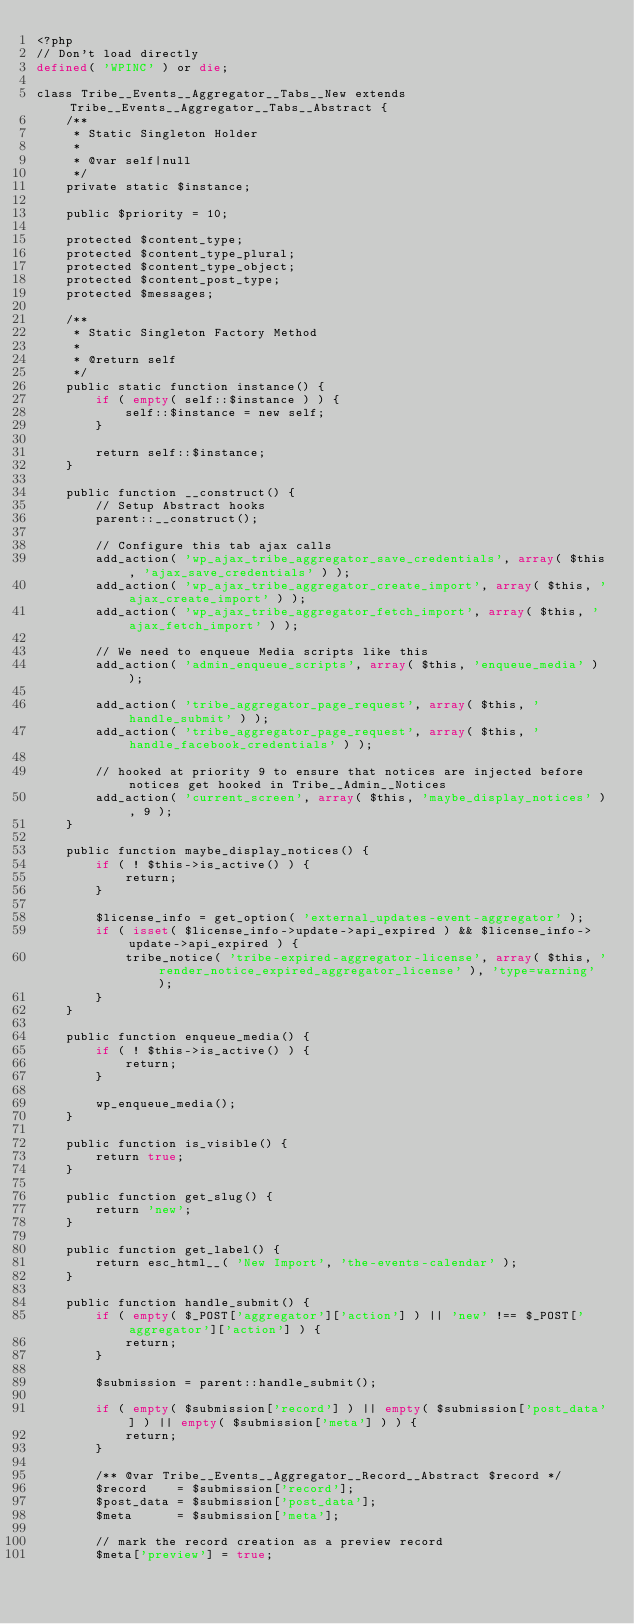<code> <loc_0><loc_0><loc_500><loc_500><_PHP_><?php
// Don't load directly
defined( 'WPINC' ) or die;

class Tribe__Events__Aggregator__Tabs__New extends Tribe__Events__Aggregator__Tabs__Abstract {
	/**
	 * Static Singleton Holder
	 *
	 * @var self|null
	 */
	private static $instance;

	public $priority = 10;

	protected $content_type;
	protected $content_type_plural;
	protected $content_type_object;
	protected $content_post_type;
	protected $messages;

	/**
	 * Static Singleton Factory Method
	 *
	 * @return self
	 */
	public static function instance() {
		if ( empty( self::$instance ) ) {
			self::$instance = new self;
		}

		return self::$instance;
	}

	public function __construct() {
		// Setup Abstract hooks
		parent::__construct();

		// Configure this tab ajax calls
		add_action( 'wp_ajax_tribe_aggregator_save_credentials', array( $this, 'ajax_save_credentials' ) );
		add_action( 'wp_ajax_tribe_aggregator_create_import', array( $this, 'ajax_create_import' ) );
		add_action( 'wp_ajax_tribe_aggregator_fetch_import', array( $this, 'ajax_fetch_import' ) );

		// We need to enqueue Media scripts like this
		add_action( 'admin_enqueue_scripts', array( $this, 'enqueue_media' ) );

		add_action( 'tribe_aggregator_page_request', array( $this, 'handle_submit' ) );
		add_action( 'tribe_aggregator_page_request', array( $this, 'handle_facebook_credentials' ) );

		// hooked at priority 9 to ensure that notices are injected before notices get hooked in Tribe__Admin__Notices
		add_action( 'current_screen', array( $this, 'maybe_display_notices' ), 9 );
	}

	public function maybe_display_notices() {
		if ( ! $this->is_active() ) {
			return;
		}

		$license_info = get_option( 'external_updates-event-aggregator' );
		if ( isset( $license_info->update->api_expired ) && $license_info->update->api_expired ) {
			tribe_notice( 'tribe-expired-aggregator-license', array( $this, 'render_notice_expired_aggregator_license' ), 'type=warning' );
		}
	}

	public function enqueue_media() {
		if ( ! $this->is_active() ) {
			return;
		}

		wp_enqueue_media();
	}

	public function is_visible() {
		return true;
	}

	public function get_slug() {
		return 'new';
	}

	public function get_label() {
		return esc_html__( 'New Import', 'the-events-calendar' );
	}

	public function handle_submit() {
		if ( empty( $_POST['aggregator']['action'] ) || 'new' !== $_POST['aggregator']['action'] ) {
			return;
		}

		$submission = parent::handle_submit();

		if ( empty( $submission['record'] ) || empty( $submission['post_data'] ) || empty( $submission['meta'] ) ) {
			return;
		}

		/** @var Tribe__Events__Aggregator__Record__Abstract $record */
		$record    = $submission['record'];
		$post_data = $submission['post_data'];
		$meta      = $submission['meta'];

		// mark the record creation as a preview record
		$meta['preview'] = true;
</code> 